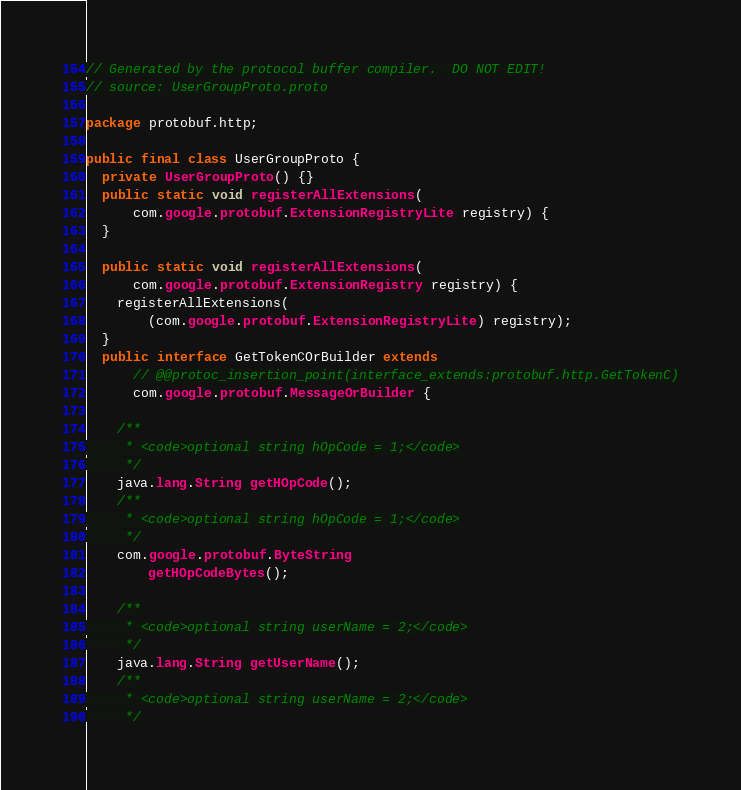Convert code to text. <code><loc_0><loc_0><loc_500><loc_500><_Java_>// Generated by the protocol buffer compiler.  DO NOT EDIT!
// source: UserGroupProto.proto

package protobuf.http;

public final class UserGroupProto {
  private UserGroupProto() {}
  public static void registerAllExtensions(
      com.google.protobuf.ExtensionRegistryLite registry) {
  }

  public static void registerAllExtensions(
      com.google.protobuf.ExtensionRegistry registry) {
    registerAllExtensions(
        (com.google.protobuf.ExtensionRegistryLite) registry);
  }
  public interface GetTokenCOrBuilder extends
      // @@protoc_insertion_point(interface_extends:protobuf.http.GetTokenC)
      com.google.protobuf.MessageOrBuilder {

    /**
     * <code>optional string hOpCode = 1;</code>
     */
    java.lang.String getHOpCode();
    /**
     * <code>optional string hOpCode = 1;</code>
     */
    com.google.protobuf.ByteString
        getHOpCodeBytes();

    /**
     * <code>optional string userName = 2;</code>
     */
    java.lang.String getUserName();
    /**
     * <code>optional string userName = 2;</code>
     */</code> 